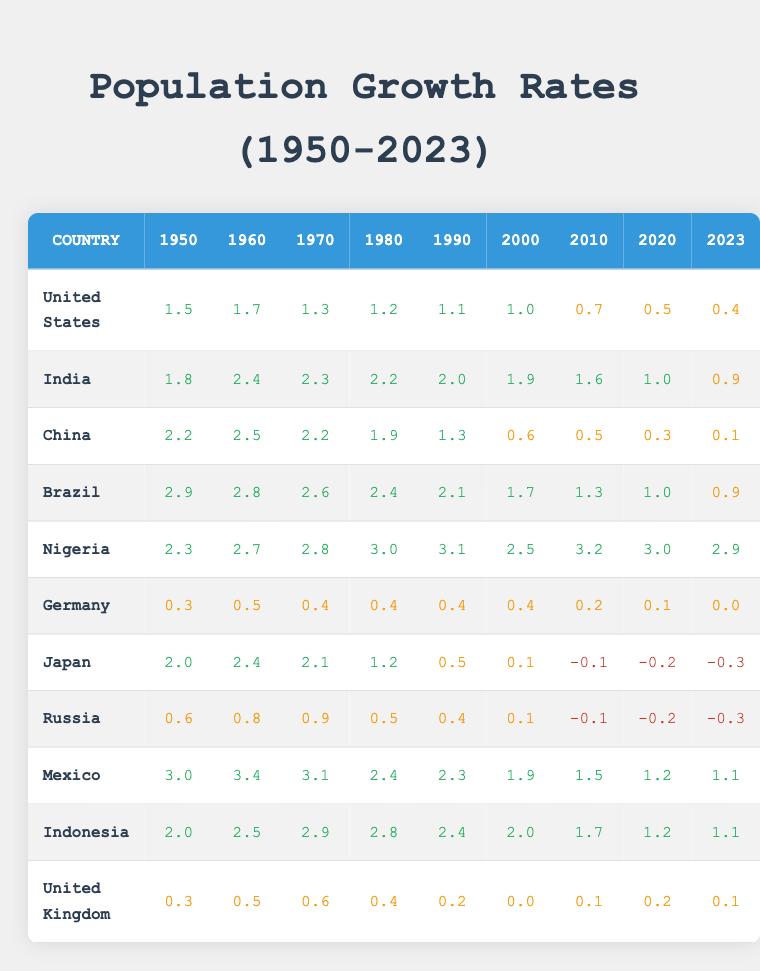What was the population growth rate of India in 1980? The table shows India's population growth rate for the year 1980 as 2.2.
Answer: 2.2 Which country had the highest population growth rate in 1950? Looking at the data for 1950, Brazil had the highest value at 2.9.
Answer: Brazil What has been the trend of population growth rate in Japan from 1950 to 2023? Japan's growth rate started at 2.0 in 1950, peaked at 2.4 in 1960, but has declined steadily, reaching -0.3 in 2023.
Answer: Steadily declining trend What is the average population growth rate of Nigeria from 1950 to 2023? The values for Nigeria are 2.3, 2.7, 2.8, 3.0, 3.1, 2.5, 3.2, 3.0, and 2.9. The sum is 24.5 and dividing by 9 gives an average of approximately 2.72.
Answer: Approximately 2.72 Did the United States experience a population growth rate higher than 1% in 2020? The table shows the U.S. population growth rate as 0.5 in 2020, which is less than 1%.
Answer: No Which countries had a negative growth rate in 2023, and what were their rates? Japan, Russia, and Germany are the only countries with negative rates in 2023, with rates of -0.3, -0.3, and 0.0 respectively.
Answer: Japan (-0.3), Russia (-0.3), Germany (0.0) What year saw the lowest growth rate in China, and what was the rate? In 2023, China recorded its lowest growth rate at 0.1.
Answer: 2023, 0.1 What is the difference in population growth rate between India and China in 2010? In 2010, India's rate was 1.6 while China's was 0.5. The difference is 1.6 - 0.5 = 1.1.
Answer: 1.1 Which country showed a consistent decline in population growth rates from 1950 to 2023? Analyzing the values, Japan consistently declined from 2.0 to -0.3.
Answer: Japan What was the growth rate of Germany in 2023, and what trend does it show? Germany's growth rate in 2023 was 0.0, which indicates a stagnation or decline.
Answer: 0.0, indicating stagnation 